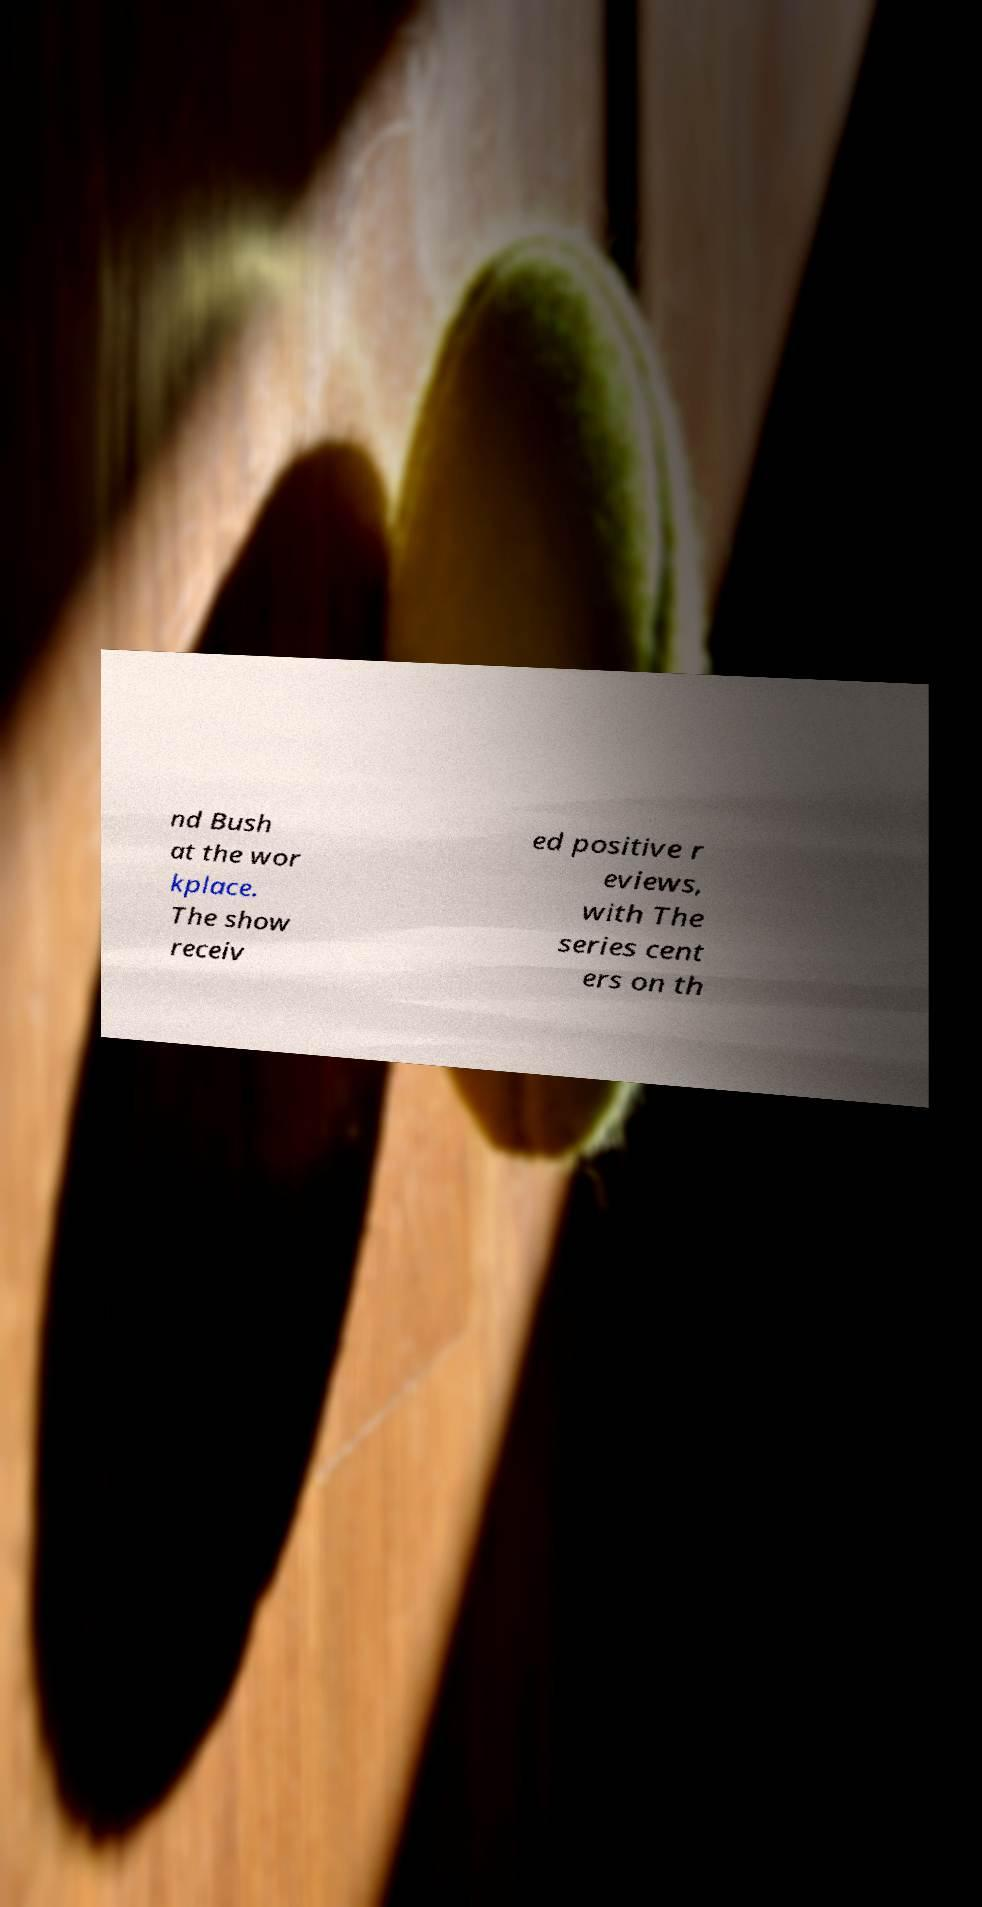I need the written content from this picture converted into text. Can you do that? nd Bush at the wor kplace. The show receiv ed positive r eviews, with The series cent ers on th 